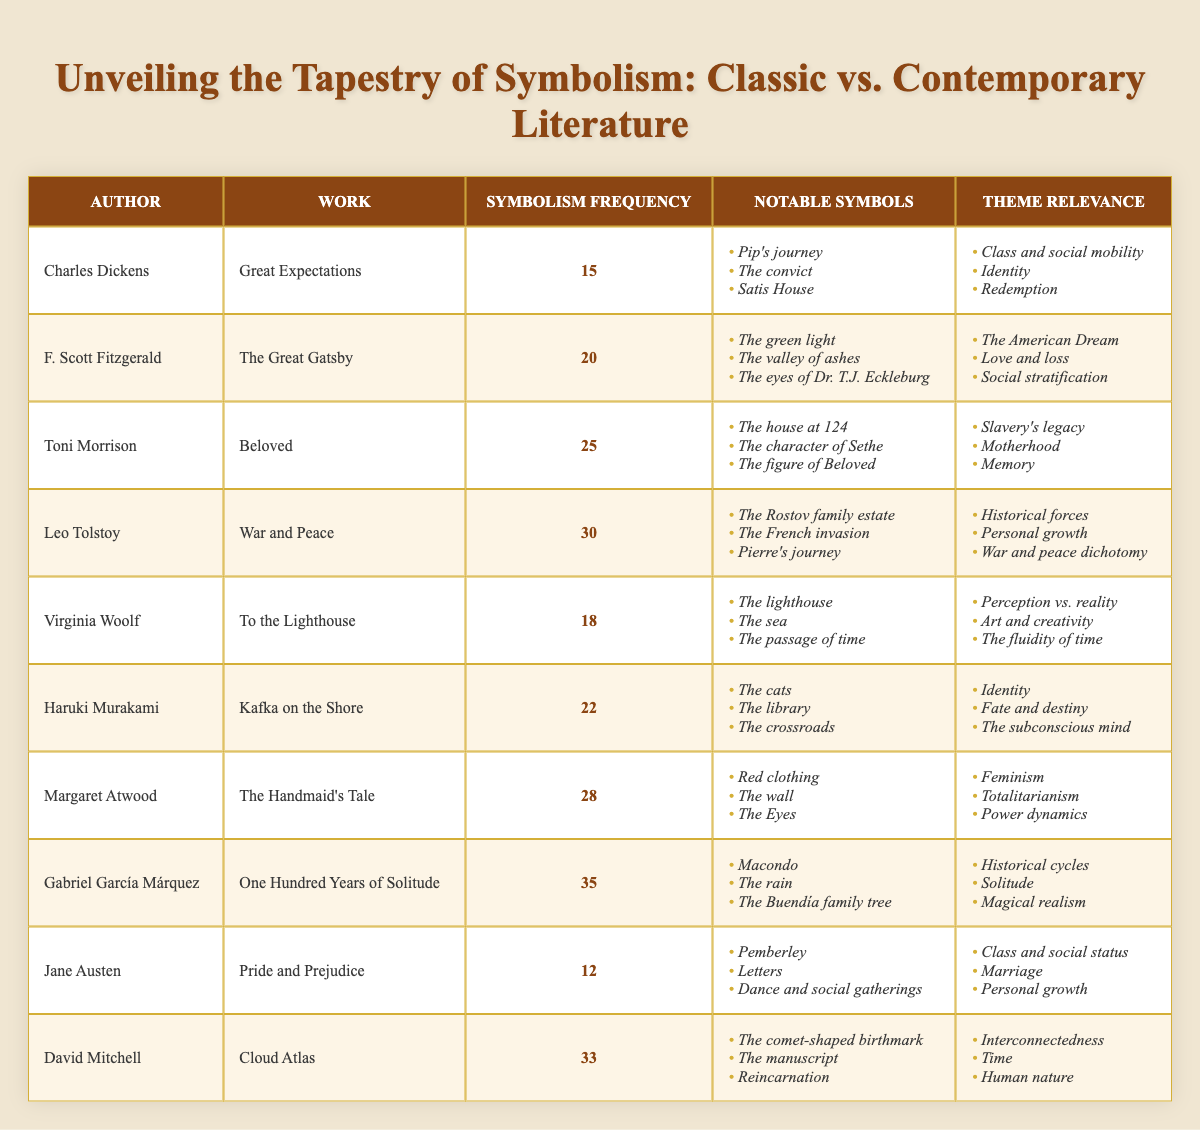What is the symbolism frequency of "Beloved"? The table lists "Beloved" by Toni Morrison with a symbolism frequency of 25.
Answer: 25 Who is the author of "The Great Gatsby"? According to the table, "The Great Gatsby" is authored by F. Scott Fitzgerald.
Answer: F. Scott Fitzgerald Which work has the highest symbolism frequency? The table indicates that "One Hundred Years of Solitude" by Gabriel García Márquez has the highest symbolism frequency of 35.
Answer: One Hundred Years of Solitude What notable symbols are associated with "War and Peace"? The notable symbols for "War and Peace" include "The Rostov family estate," "The French invasion," and "Pierre's journey."
Answer: The Rostov family estate, The French invasion, Pierre's journey What is the average symbolism frequency of the classic authors listed? First, we determine the frequencies of the classic authors: Dickens (15), Fitzgerald (20), Tolstoy (30), Austen (12) totaling 77. The average is then calculated by dividing by 4, which results in 19.25.
Answer: 19.25 Does "The Handmaid's Tale" have a symbolism frequency greater than 25? The table shows that the frequency for "The Handmaid's Tale" is 28, which is indeed greater than 25.
Answer: Yes How does the symbolism frequency of "Cloud Atlas" compare to that of "Pride and Prejudice"? The frequency for "Cloud Atlas" is 33, while "Pride and Prejudice" has a frequency of 12. Therefore, "Cloud Atlas" has a frequency that is 21 bigger than that of "Pride and Prejudice."
Answer: 21 Calculate the difference in symbolism frequency between the work with the highest and lowest frequency among the authors listed. The highest frequency is 35 for "One Hundred Years of Solitude" and the lowest is 12 for "Pride and Prejudice." The difference is 35 - 12 = 23.
Answer: 23 Which contemporary author's work has the most relevant theme of "Feminism"? "The Handmaid's Tale" by Margaret Atwood is listed under the theme of "Feminism," making her the contemporary author identifying with that theme.
Answer: Margaret Atwood What are the notable symbols in "Kafka on the Shore"? The table lists the notable symbols for "Kafka on the Shore" as "The cats," "The library," and "The crossroads."
Answer: The cats, The library, The crossroads 